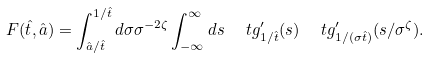<formula> <loc_0><loc_0><loc_500><loc_500>F ( \hat { t } , \hat { a } ) = \int _ { \hat { a } / \hat { t } } ^ { 1 / \hat { t } } d \sigma \sigma ^ { - 2 \zeta } \int _ { - \infty } ^ { \infty } d s \ \ t g ^ { \prime } _ { 1 / \hat { t } } ( s ) \ \ t g ^ { \prime } _ { 1 / ( \sigma \hat { t } ) } ( s / \sigma ^ { \zeta } ) .</formula> 